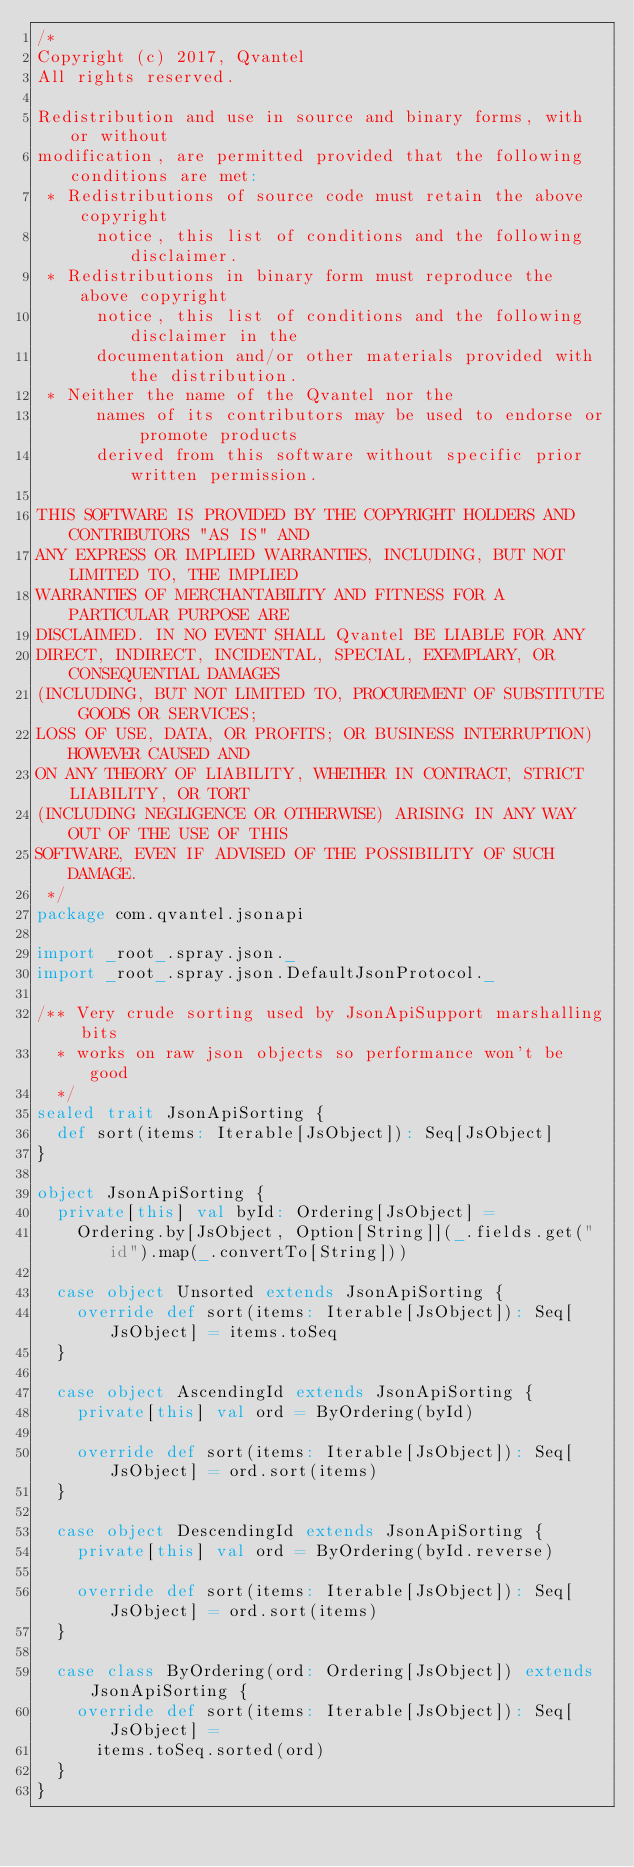Convert code to text. <code><loc_0><loc_0><loc_500><loc_500><_Scala_>/*
Copyright (c) 2017, Qvantel
All rights reserved.

Redistribution and use in source and binary forms, with or without
modification, are permitted provided that the following conditions are met:
 * Redistributions of source code must retain the above copyright
      notice, this list of conditions and the following disclaimer.
 * Redistributions in binary form must reproduce the above copyright
      notice, this list of conditions and the following disclaimer in the
      documentation and/or other materials provided with the distribution.
 * Neither the name of the Qvantel nor the
      names of its contributors may be used to endorse or promote products
      derived from this software without specific prior written permission.

THIS SOFTWARE IS PROVIDED BY THE COPYRIGHT HOLDERS AND CONTRIBUTORS "AS IS" AND
ANY EXPRESS OR IMPLIED WARRANTIES, INCLUDING, BUT NOT LIMITED TO, THE IMPLIED
WARRANTIES OF MERCHANTABILITY AND FITNESS FOR A PARTICULAR PURPOSE ARE
DISCLAIMED. IN NO EVENT SHALL Qvantel BE LIABLE FOR ANY
DIRECT, INDIRECT, INCIDENTAL, SPECIAL, EXEMPLARY, OR CONSEQUENTIAL DAMAGES
(INCLUDING, BUT NOT LIMITED TO, PROCUREMENT OF SUBSTITUTE GOODS OR SERVICES;
LOSS OF USE, DATA, OR PROFITS; OR BUSINESS INTERRUPTION) HOWEVER CAUSED AND
ON ANY THEORY OF LIABILITY, WHETHER IN CONTRACT, STRICT LIABILITY, OR TORT
(INCLUDING NEGLIGENCE OR OTHERWISE) ARISING IN ANY WAY OUT OF THE USE OF THIS
SOFTWARE, EVEN IF ADVISED OF THE POSSIBILITY OF SUCH DAMAGE.
 */
package com.qvantel.jsonapi

import _root_.spray.json._
import _root_.spray.json.DefaultJsonProtocol._

/** Very crude sorting used by JsonApiSupport marshalling bits
  * works on raw json objects so performance won't be good
  */
sealed trait JsonApiSorting {
  def sort(items: Iterable[JsObject]): Seq[JsObject]
}

object JsonApiSorting {
  private[this] val byId: Ordering[JsObject] =
    Ordering.by[JsObject, Option[String]](_.fields.get("id").map(_.convertTo[String]))

  case object Unsorted extends JsonApiSorting {
    override def sort(items: Iterable[JsObject]): Seq[JsObject] = items.toSeq
  }

  case object AscendingId extends JsonApiSorting {
    private[this] val ord = ByOrdering(byId)

    override def sort(items: Iterable[JsObject]): Seq[JsObject] = ord.sort(items)
  }

  case object DescendingId extends JsonApiSorting {
    private[this] val ord = ByOrdering(byId.reverse)

    override def sort(items: Iterable[JsObject]): Seq[JsObject] = ord.sort(items)
  }

  case class ByOrdering(ord: Ordering[JsObject]) extends JsonApiSorting {
    override def sort(items: Iterable[JsObject]): Seq[JsObject] =
      items.toSeq.sorted(ord)
  }
}
</code> 